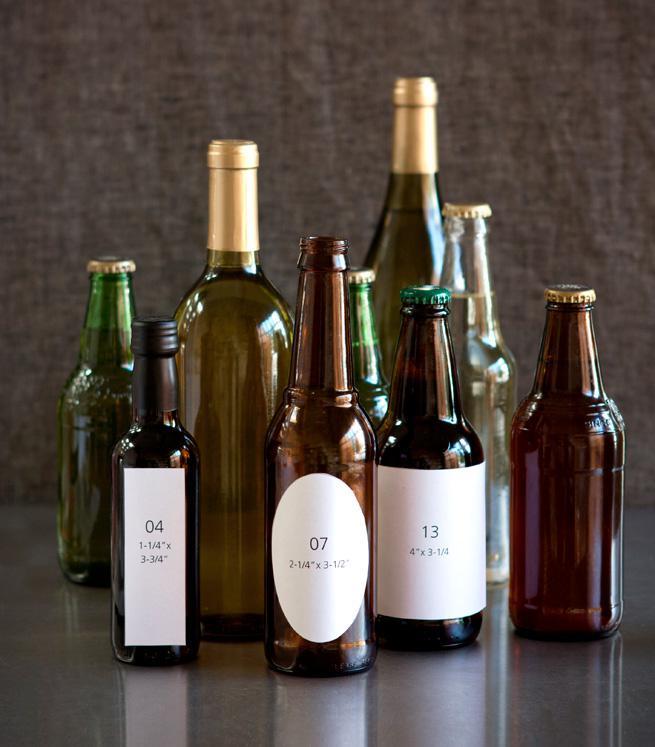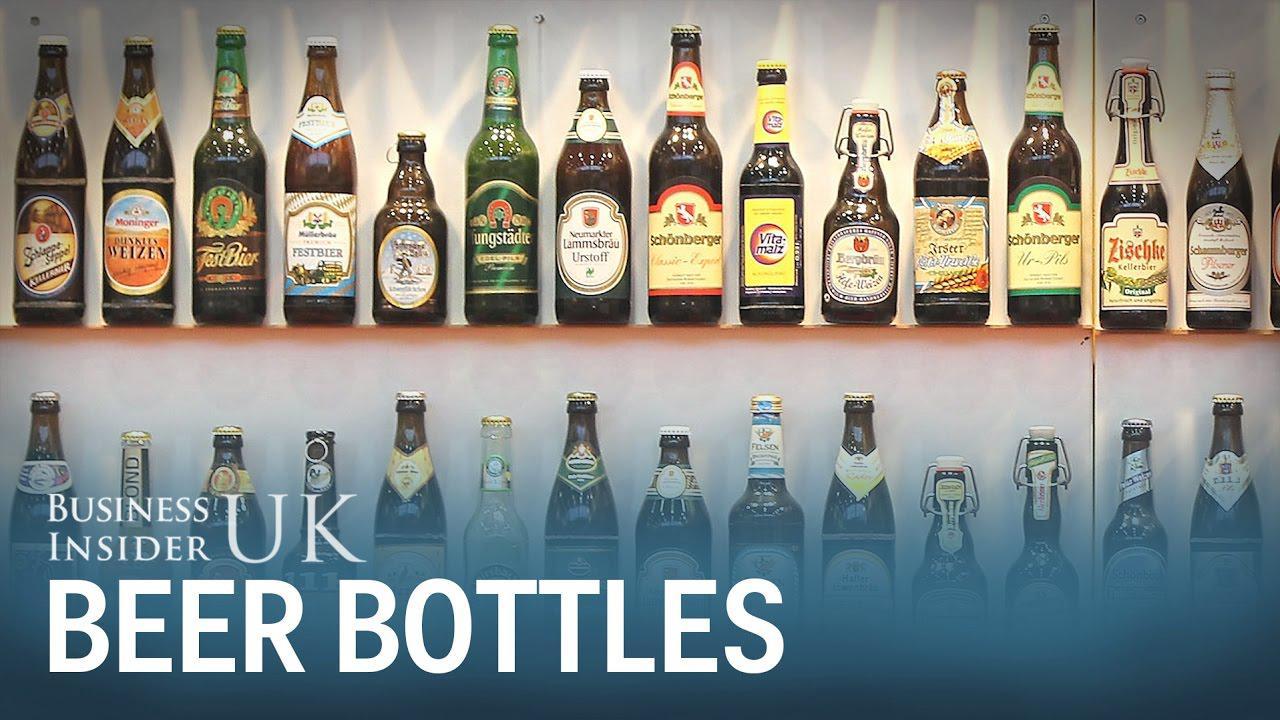The first image is the image on the left, the second image is the image on the right. For the images displayed, is the sentence "One image shows a variety of glass bottle shapes, colors and sizes displayed upright on a flat surface, with bottles overlapping." factually correct? Answer yes or no. Yes. The first image is the image on the left, the second image is the image on the right. Evaluate the accuracy of this statement regarding the images: "In at least one image there are nine bottles of alcohol.". Is it true? Answer yes or no. Yes. 